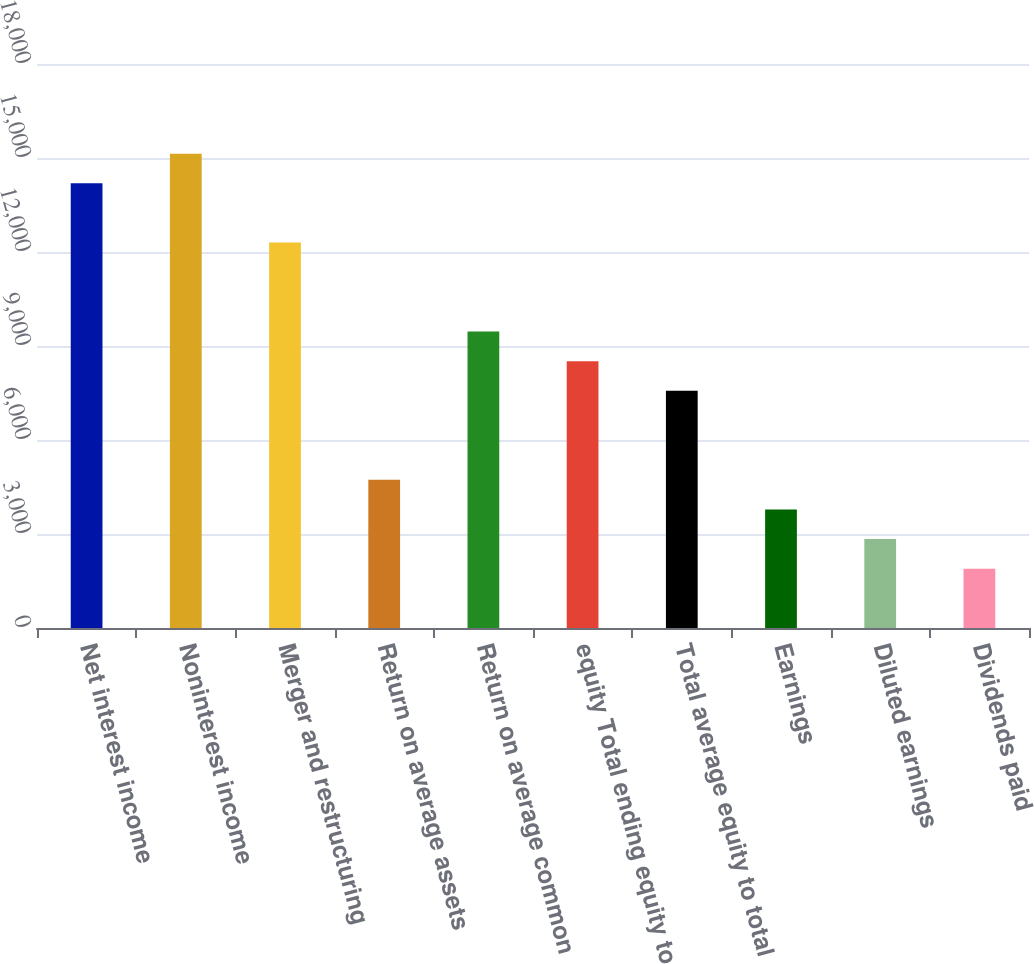Convert chart to OTSL. <chart><loc_0><loc_0><loc_500><loc_500><bar_chart><fcel>Net interest income<fcel>Noninterest income<fcel>Merger and restructuring<fcel>Return on average assets<fcel>Return on average common<fcel>equity Total ending equity to<fcel>Total average equity to total<fcel>Earnings<fcel>Diluted earnings<fcel>Dividends paid<nl><fcel>14192.8<fcel>15139<fcel>12300.5<fcel>4731.11<fcel>9461.96<fcel>8515.79<fcel>7569.62<fcel>3784.94<fcel>2838.77<fcel>1892.6<nl></chart> 